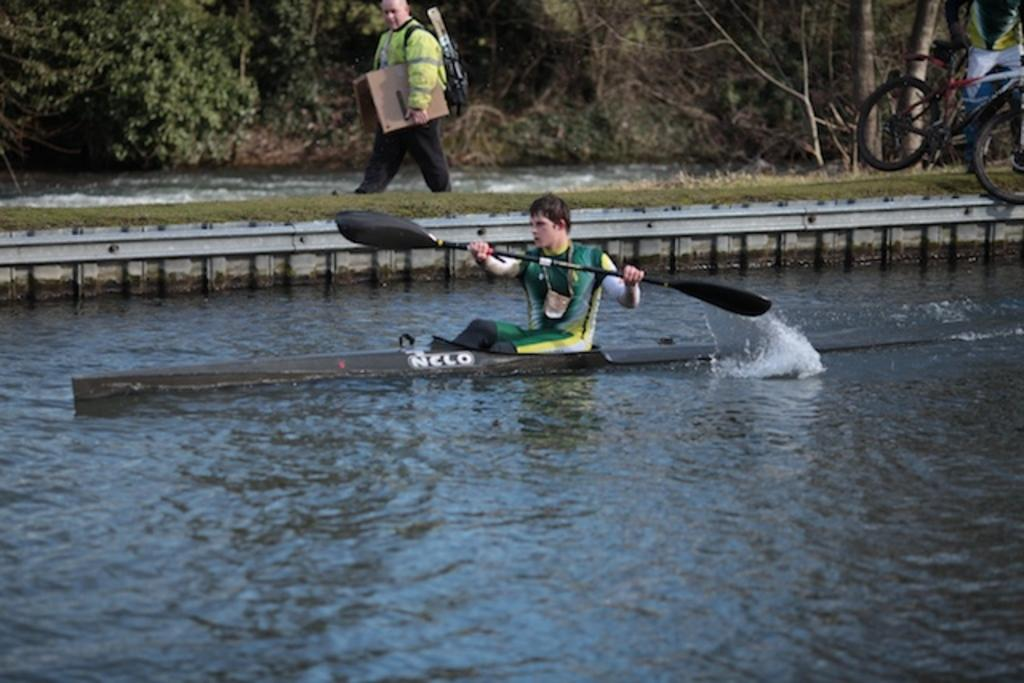What is the main subject in the center of the image? There is a person on a boat in the center of the image. What is the boat doing in the image? The boat is sailing on water. What can be seen in the background of the image? In the background, there is a person walking, grass, a bicycle, water, and trees. What grade is the worm receiving in the image? There is no worm present in the image, so it is not possible to determine any grade. 